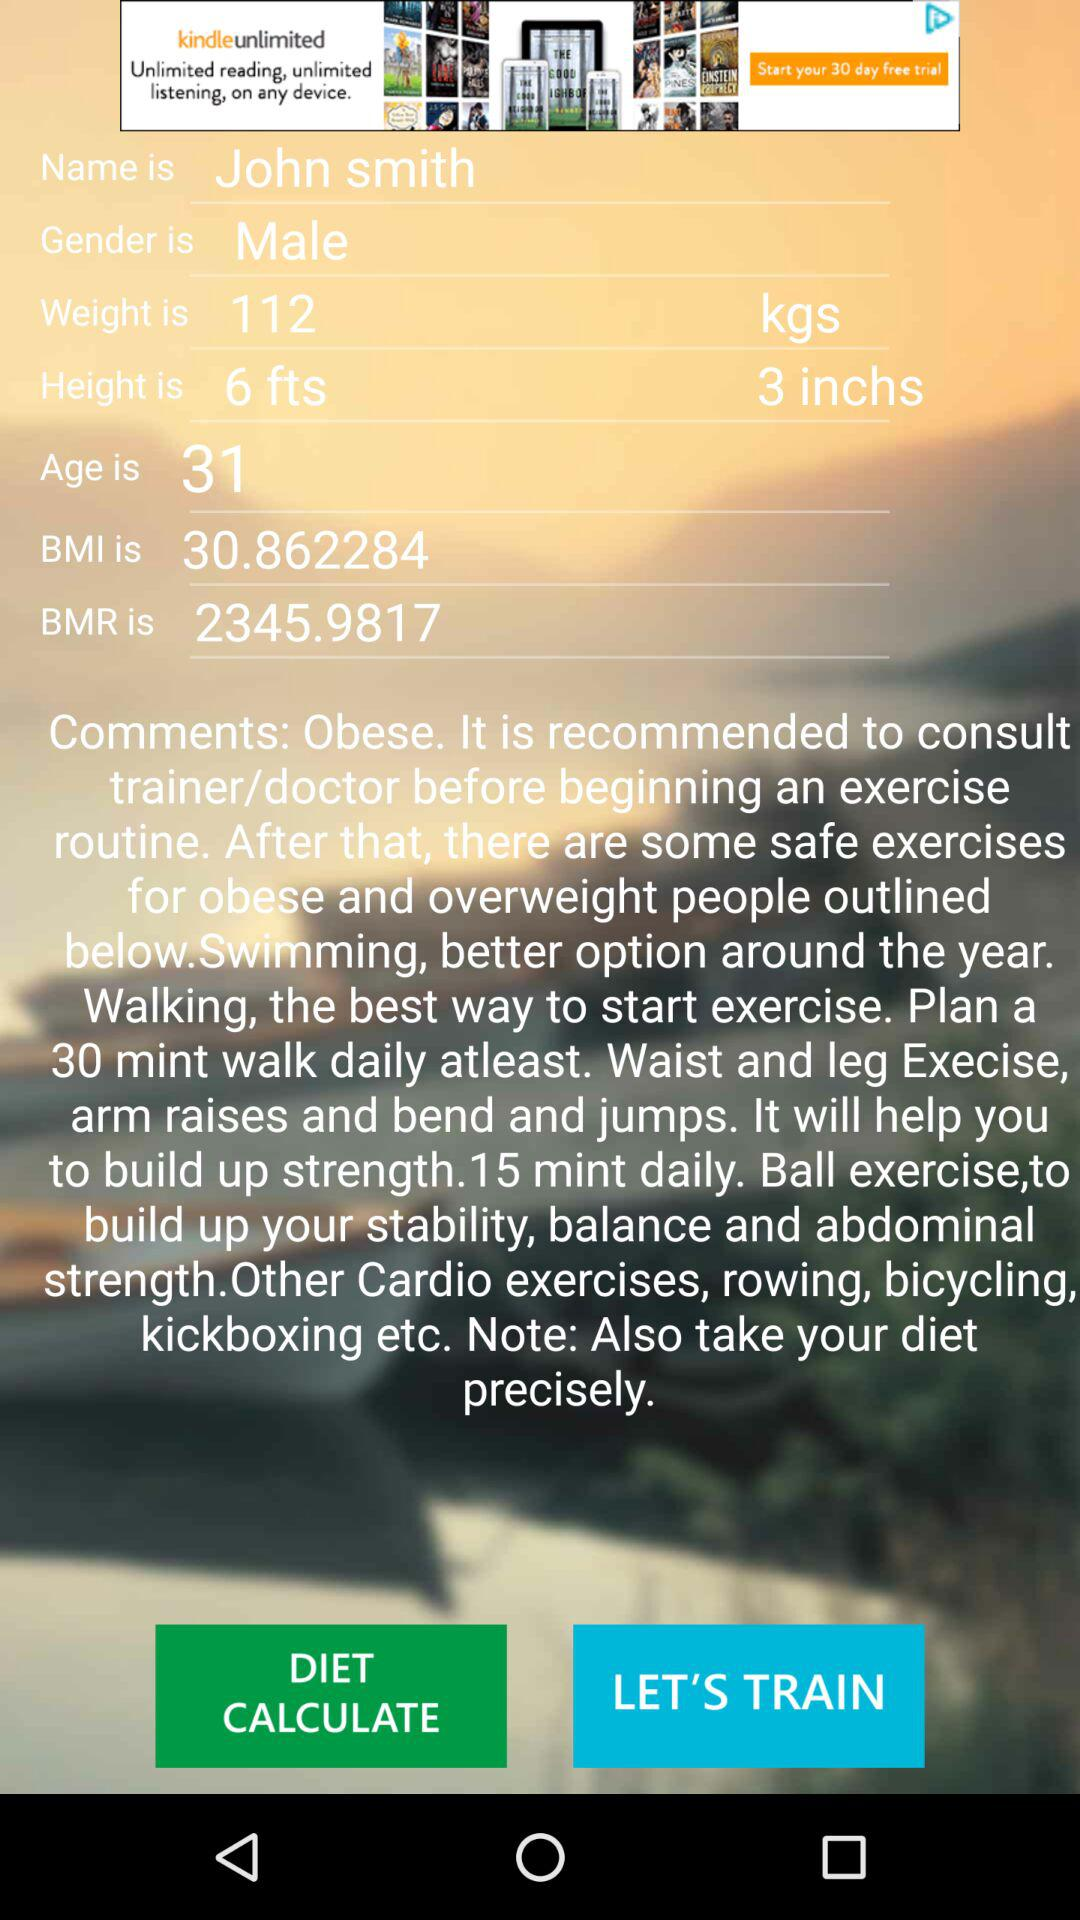What is the age? The age is 31. 